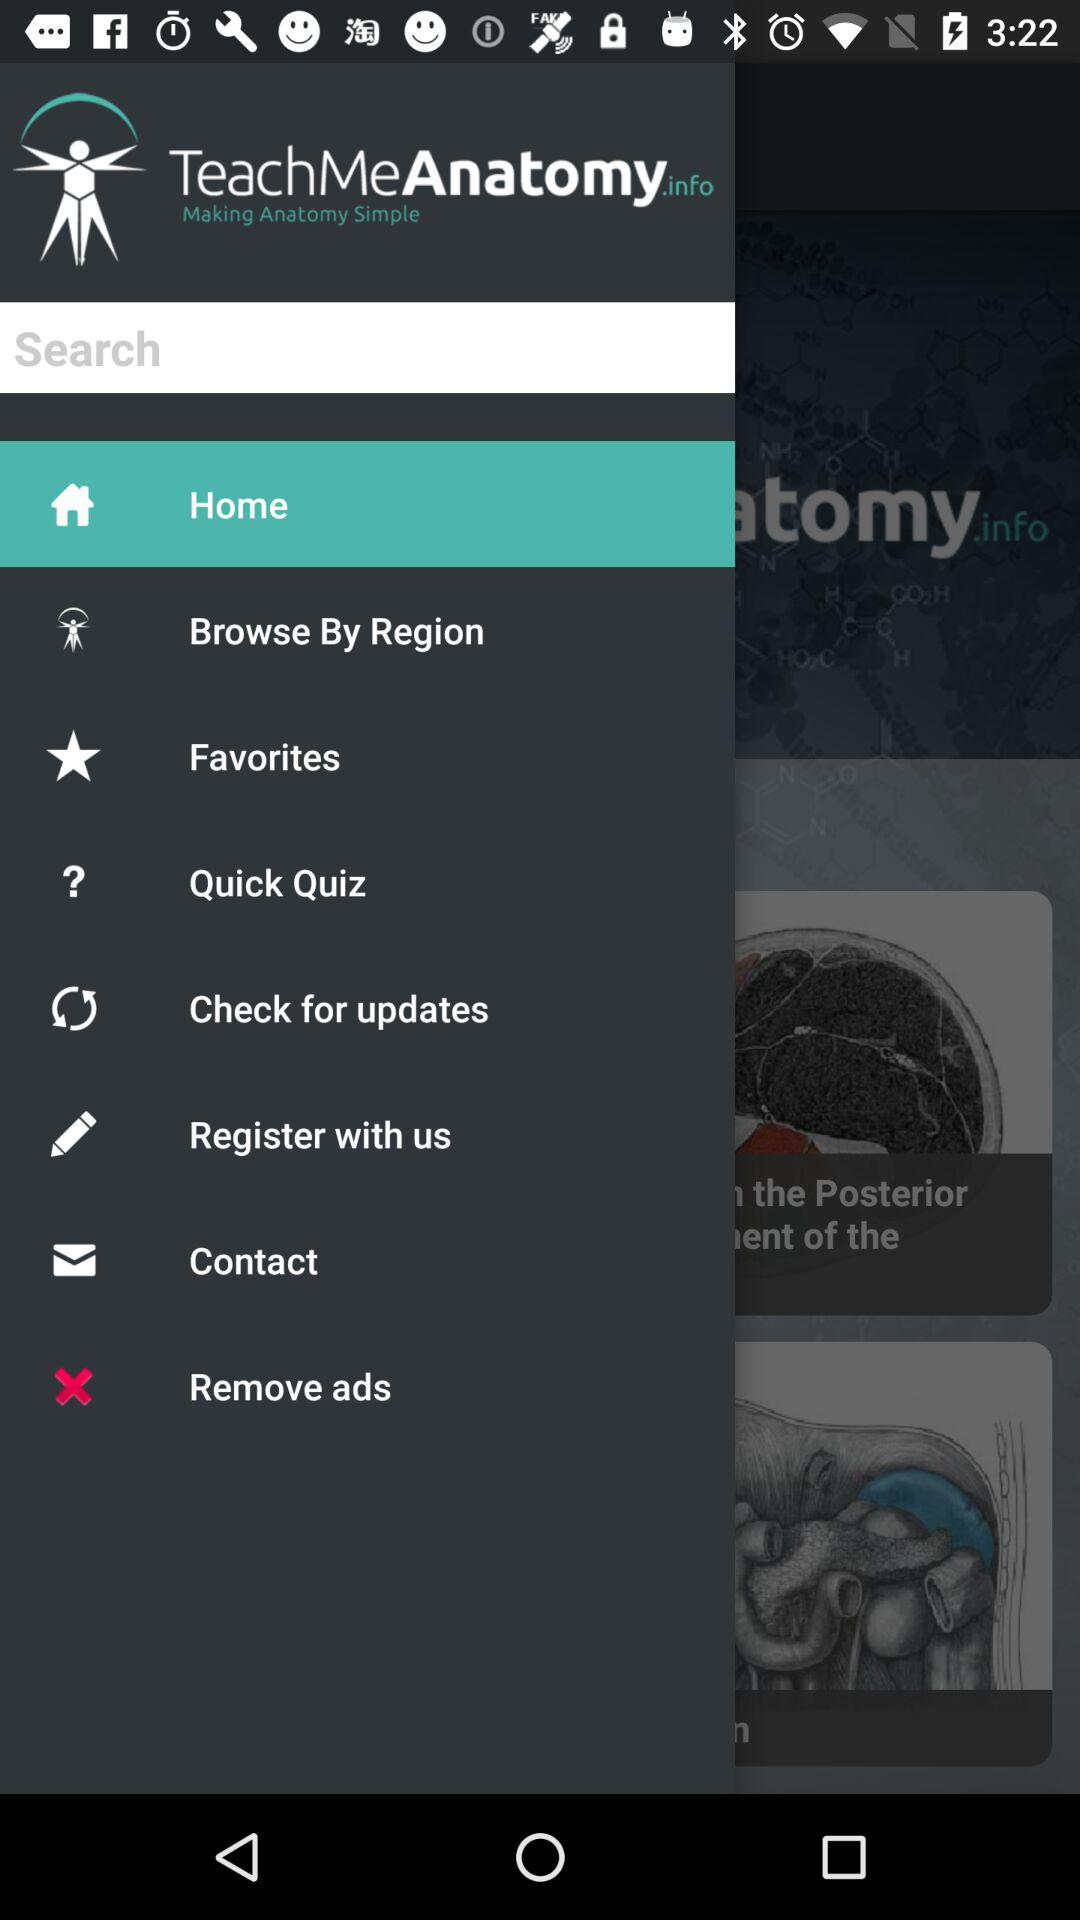Which item is selected in the menu? The selected item is "Home". 